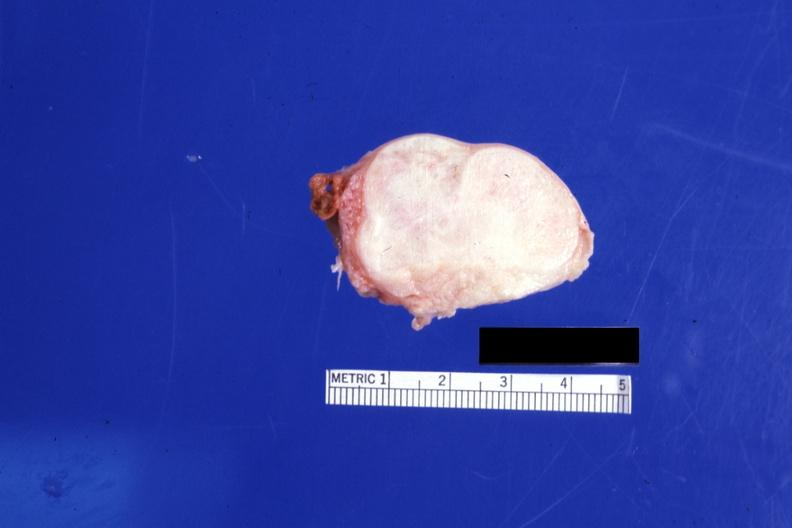does this image show cut surface 4 cm lesion 76yobf?
Answer the question using a single word or phrase. Yes 